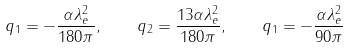Convert formula to latex. <formula><loc_0><loc_0><loc_500><loc_500>q _ { 1 } = - \frac { \alpha \lambda ^ { 2 } _ { e } } { 1 8 0 \pi } , \quad q _ { 2 } = \frac { 1 3 \alpha \lambda ^ { 2 } _ { e } } { 1 8 0 \pi } , \quad q _ { 1 } = - \frac { \alpha \lambda ^ { 2 } _ { e } } { 9 0 \pi }</formula> 